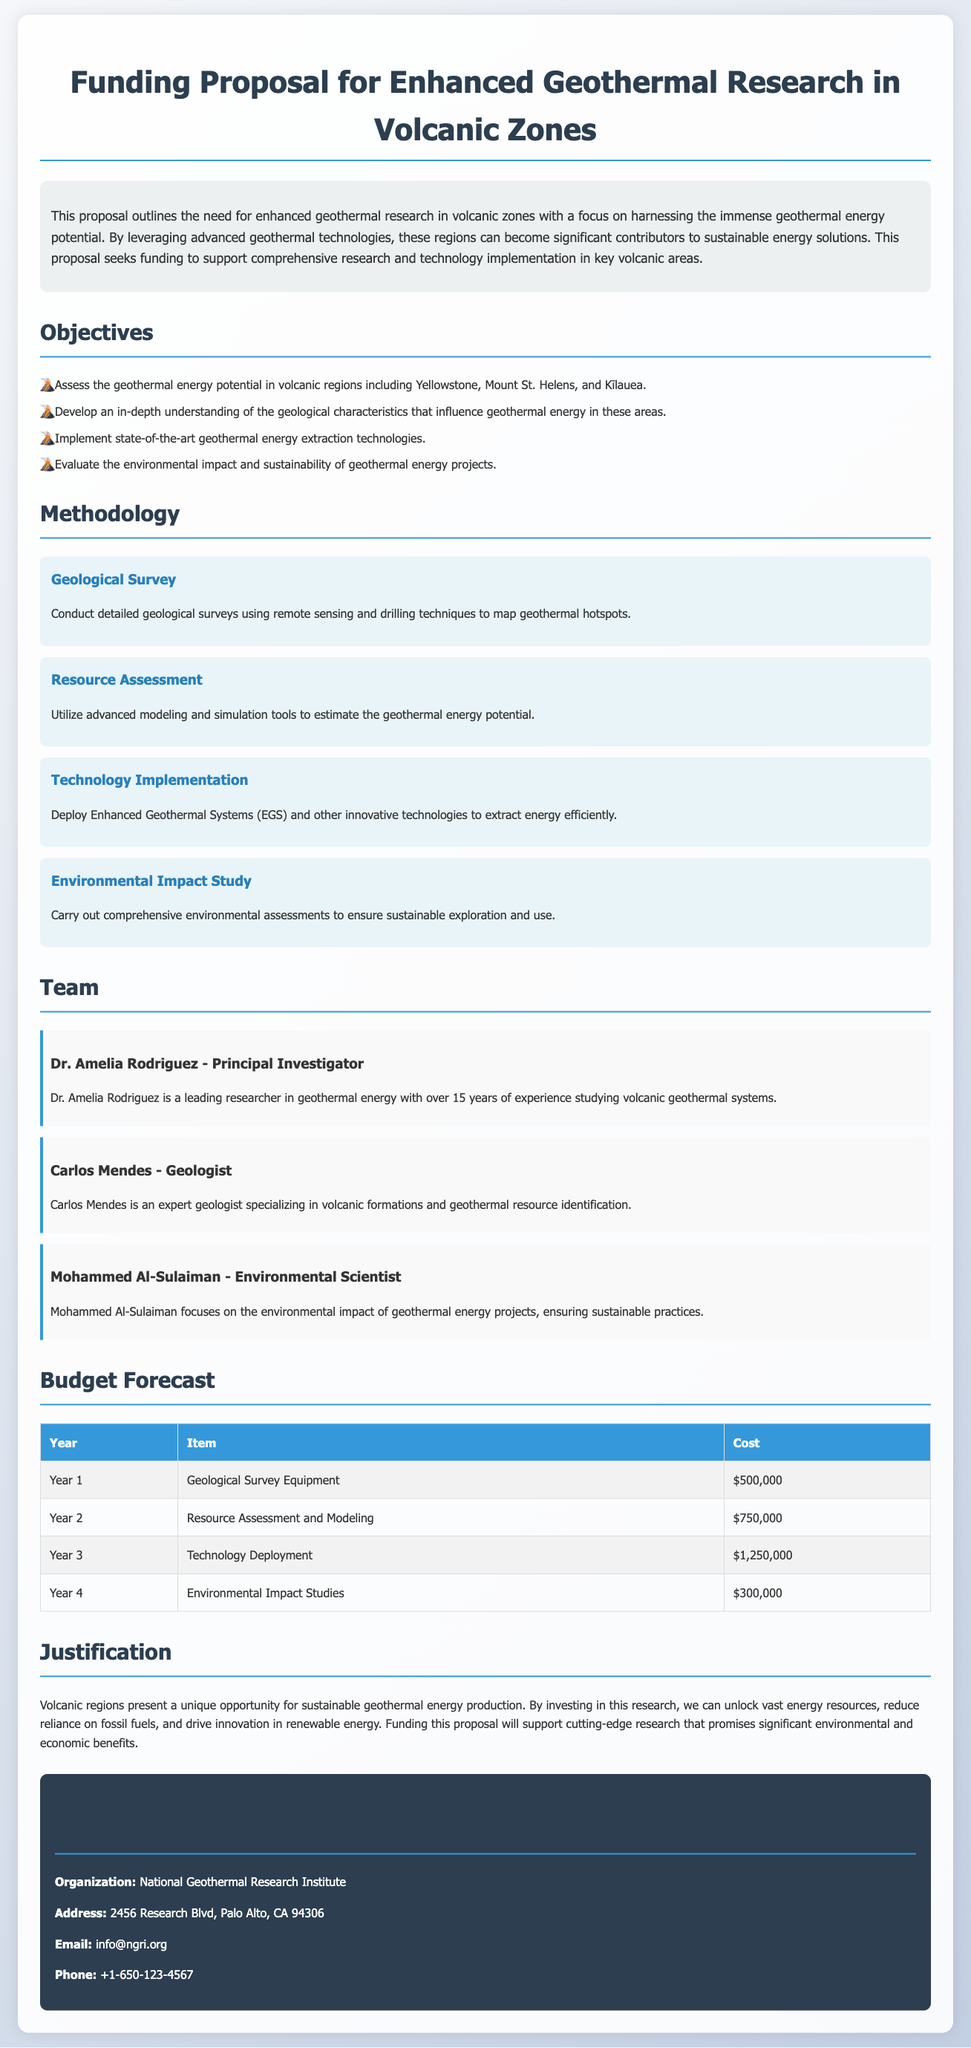what is the title of the proposal? The title of the proposal is provided at the top of the document.
Answer: Funding Proposal for Enhanced Geothermal Research in Volcanic Zones who is the principal investigator? The principal investigator is named in the team section of the document.
Answer: Dr. Amelia Rodriguez how much is allocated for geological survey equipment? This amount is specified in the budget forecast table.
Answer: $500,000 what is the focus of the environmental impact study methodology? This is outlined in the methodology section under its respective heading.
Answer: Sustainable exploration and use which year has the highest budget allocation? The budget forecast table allows for comparison of year allocations.
Answer: Year 3 what organization is mentioned in the contact information? The organization's name is listed at the end of the document.
Answer: National Geothermal Research Institute what are the objectives of the proposal? The objectives are listed under a specific heading and can be summarized.
Answer: Assess, develop, implement, evaluate what type of research is highlighted as crucial in volcanic regions? The document specifies a particular kind of energy research.
Answer: Geothermal energy production how many steps are outlined in the methodology section? The number of steps can be counted in the methodology section.
Answer: Four 